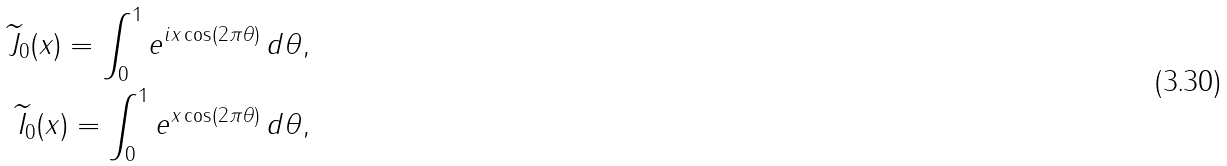<formula> <loc_0><loc_0><loc_500><loc_500>\widetilde { J } _ { 0 } ( x ) = \int ^ { 1 } _ { 0 } { e ^ { i x \cos ( 2 \pi \theta ) } \, d \theta } , \\ \widetilde { I } _ { 0 } ( x ) = \int ^ { 1 } _ { 0 } { e ^ { x \cos ( 2 \pi \theta ) } \, d \theta } ,</formula> 